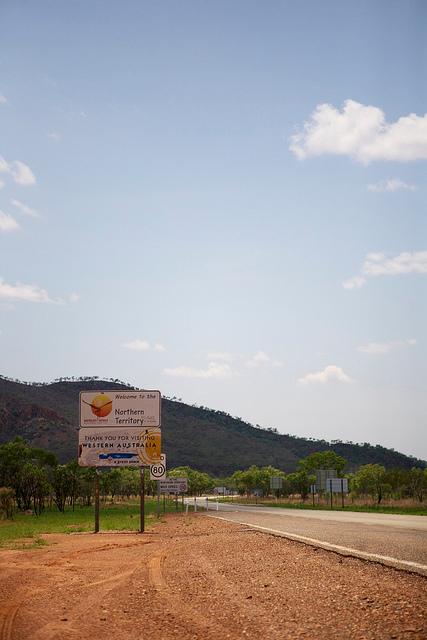What's the speed limit?
Answer briefly. 55. How many signs are on the edge of the field?
Write a very short answer. 2. What word is on the top of the sign?
Keep it brief. Welcome. What highway is the sign pointing towards?
Give a very brief answer. 1 on right. What kind of road is this?
Short answer required. Dirt. Is this a desert?
Quick response, please. No. What type of ground is the sign on?
Write a very short answer. Dirt. Is this in a parka?
Answer briefly. No. Are there clouds in the sky?
Concise answer only. Yes. 